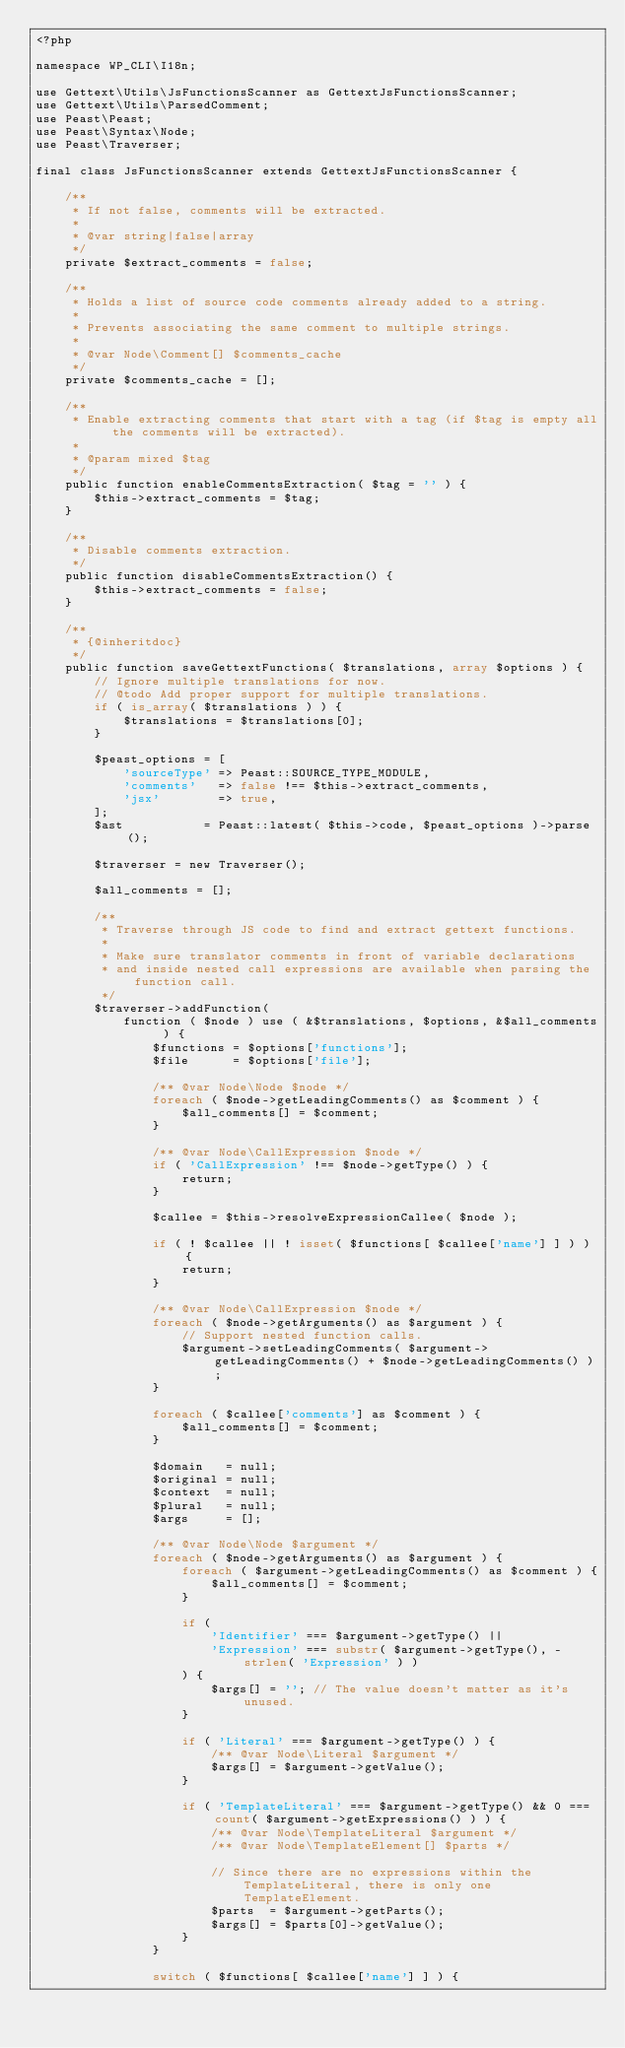<code> <loc_0><loc_0><loc_500><loc_500><_PHP_><?php

namespace WP_CLI\I18n;

use Gettext\Utils\JsFunctionsScanner as GettextJsFunctionsScanner;
use Gettext\Utils\ParsedComment;
use Peast\Peast;
use Peast\Syntax\Node;
use Peast\Traverser;

final class JsFunctionsScanner extends GettextJsFunctionsScanner {

	/**
	 * If not false, comments will be extracted.
	 *
	 * @var string|false|array
	 */
	private $extract_comments = false;

	/**
	 * Holds a list of source code comments already added to a string.
	 *
	 * Prevents associating the same comment to multiple strings.
	 *
	 * @var Node\Comment[] $comments_cache
	 */
	private $comments_cache = [];

	/**
	 * Enable extracting comments that start with a tag (if $tag is empty all the comments will be extracted).
	 *
	 * @param mixed $tag
	 */
	public function enableCommentsExtraction( $tag = '' ) {
		$this->extract_comments = $tag;
	}

	/**
	 * Disable comments extraction.
	 */
	public function disableCommentsExtraction() {
		$this->extract_comments = false;
	}

	/**
	 * {@inheritdoc}
	 */
	public function saveGettextFunctions( $translations, array $options ) {
		// Ignore multiple translations for now.
		// @todo Add proper support for multiple translations.
		if ( is_array( $translations ) ) {
			$translations = $translations[0];
		}

		$peast_options = [
			'sourceType' => Peast::SOURCE_TYPE_MODULE,
			'comments'   => false !== $this->extract_comments,
			'jsx'        => true,
		];
		$ast           = Peast::latest( $this->code, $peast_options )->parse();

		$traverser = new Traverser();

		$all_comments = [];

		/**
		 * Traverse through JS code to find and extract gettext functions.
		 *
		 * Make sure translator comments in front of variable declarations
		 * and inside nested call expressions are available when parsing the function call.
		 */
		$traverser->addFunction(
			function ( $node ) use ( &$translations, $options, &$all_comments ) {
				$functions = $options['functions'];
				$file      = $options['file'];

				/** @var Node\Node $node */
				foreach ( $node->getLeadingComments() as $comment ) {
					$all_comments[] = $comment;
				}

				/** @var Node\CallExpression $node */
				if ( 'CallExpression' !== $node->getType() ) {
					return;
				}

				$callee = $this->resolveExpressionCallee( $node );

				if ( ! $callee || ! isset( $functions[ $callee['name'] ] ) ) {
					return;
				}

				/** @var Node\CallExpression $node */
				foreach ( $node->getArguments() as $argument ) {
					// Support nested function calls.
					$argument->setLeadingComments( $argument->getLeadingComments() + $node->getLeadingComments() );
				}

				foreach ( $callee['comments'] as $comment ) {
					$all_comments[] = $comment;
				}

				$domain   = null;
				$original = null;
				$context  = null;
				$plural   = null;
				$args     = [];

				/** @var Node\Node $argument */
				foreach ( $node->getArguments() as $argument ) {
					foreach ( $argument->getLeadingComments() as $comment ) {
						$all_comments[] = $comment;
					}

					if (
						'Identifier' === $argument->getType() ||
						'Expression' === substr( $argument->getType(), -strlen( 'Expression' ) )
					) {
						$args[] = ''; // The value doesn't matter as it's unused.
					}

					if ( 'Literal' === $argument->getType() ) {
						/** @var Node\Literal $argument */
						$args[] = $argument->getValue();
					}

					if ( 'TemplateLiteral' === $argument->getType() && 0 === count( $argument->getExpressions() ) ) {
						/** @var Node\TemplateLiteral $argument */
						/** @var Node\TemplateElement[] $parts */

						// Since there are no expressions within the TemplateLiteral, there is only one TemplateElement.
						$parts  = $argument->getParts();
						$args[] = $parts[0]->getValue();
					}
				}

				switch ( $functions[ $callee['name'] ] ) {</code> 